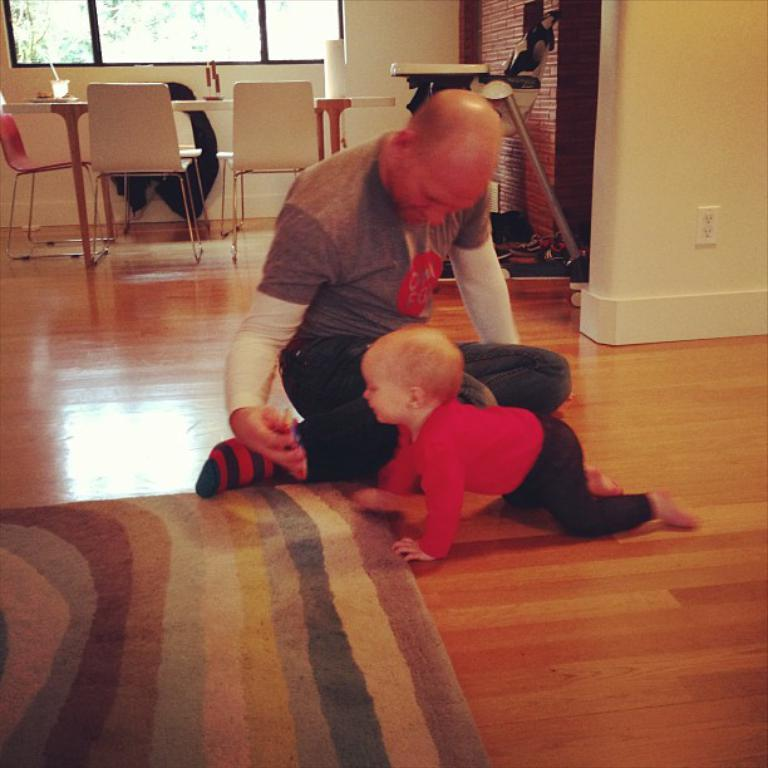What is the position of the person in the image? There is a person sitting on the floor in the image. What is the baby doing in the image? A baby is crawling in front of the person in the image. What can be seen behind the person and baby? There is a table behind the person and baby in the image. What furniture is near the table? There are chairs near the table in the image. Where is the window located in the room? There is a window at the back of the room in the image. What type of kitty is playing with an ornament on the table in the image? There is no kitty or ornament present on the table in the image. Is the person in the image playing baseball with the baby? There is no indication of a baseball or any baseball-related activity in the image. 